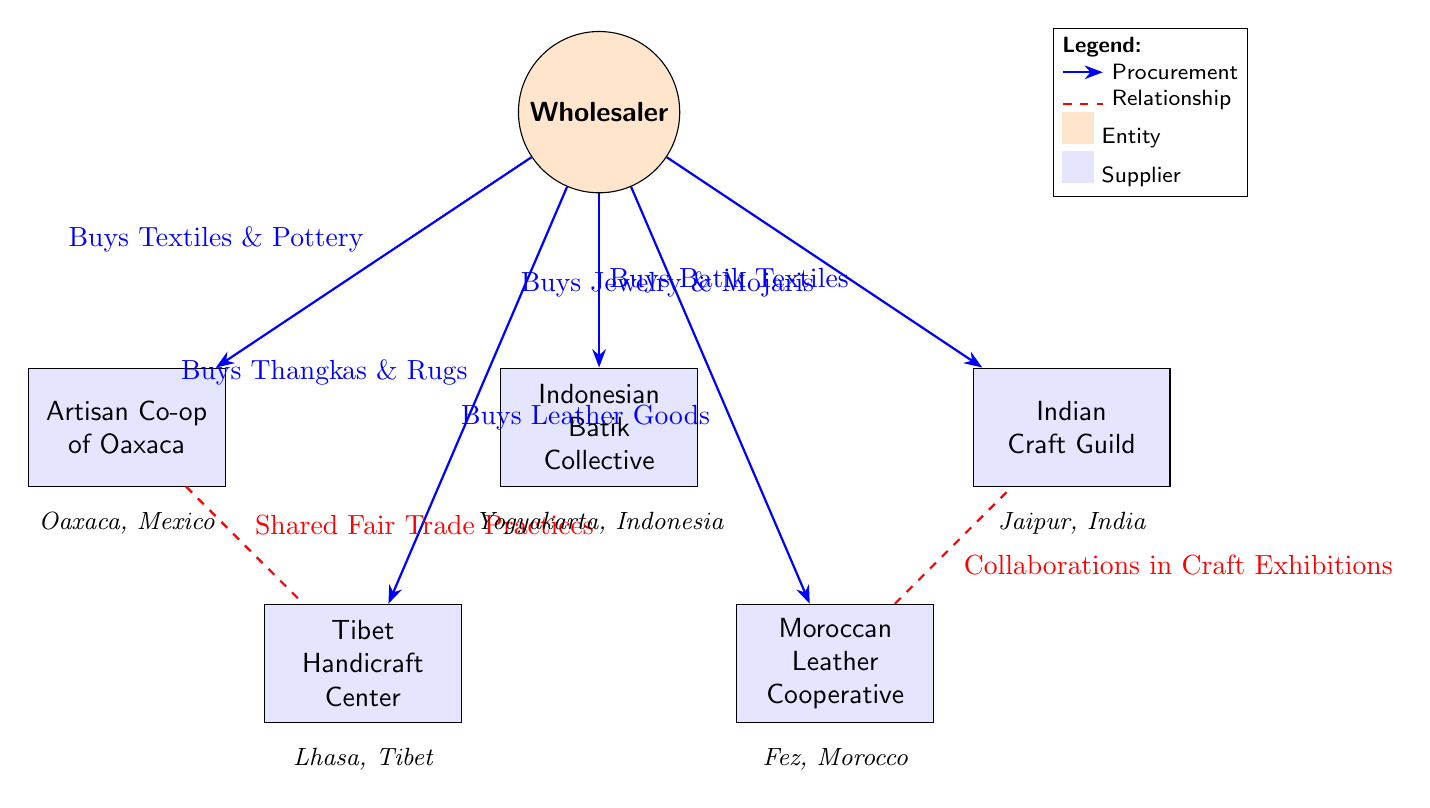What is the name of the wholesaler? The diagram identifies the wholesaler simply as "Wholesaler," which is placed at the top of the diagram.
Answer: Wholesaler How many artisan suppliers are shown in the diagram? The diagram displays five different artisan suppliers, all of which are distinctly represented with rectangular nodes connected to the wholesaler.
Answer: 5 What product does the Wholesaler buy from the Indian Craft Guild? The arrows leading from the Wholesaler to the Indian Craft Guild indicate that the Wholesaler buys "Jewelry & Mojaris" from this supplier.
Answer: Jewelry & Mojaris Which suppliers have a shared relationship? The diagram shows a dashed arrow indicating a relationship between the Artisan Co-op of Oaxaca and the Tibet Handicraft Center, implying a connection related to "Shared Fair Trade Practices."
Answer: Artisan Co-op of Oaxaca and Tibet Handicraft Center What type of goods does the Wholesaler purchase from the Indonesian Batik Collective? According to the diagram, the Wholesaler purchases "Batik Textiles" from the Indonesian Batik Collective, as noted by the connecting arrow.
Answer: Batik Textiles What collaboration is mentioned between suppliers? The diagram indicates that there is a collaboration in craft exhibitions between the Moroccan Leather Cooperative and the Indian Craft Guild, as shown by the dashed relationship arrow connecting these two suppliers.
Answer: Collaborations in Craft Exhibitions Which artisan supplier is located in Morocco? The Moroccan Leather Cooperative is the only supplier noted to be from Morocco, as indicated in the diagram with its specific geographic label.
Answer: Moroccan Leather Cooperative Identify the geographic location of the Tibetan supplier. The Tibet Handicraft Center is indicated in the diagram with a specific label stating that it is located in Lhasa, Tibet, which clarifies its geographic distribution.
Answer: Lhasa, Tibet What types of products does the Wholesaler buy from the Oaxaca supplier? The arrow pointing from the Wholesaler to the Artisan Co-op of Oaxaca specifies that the goods purchased are "Textiles & Pottery."
Answer: Textiles & Pottery 